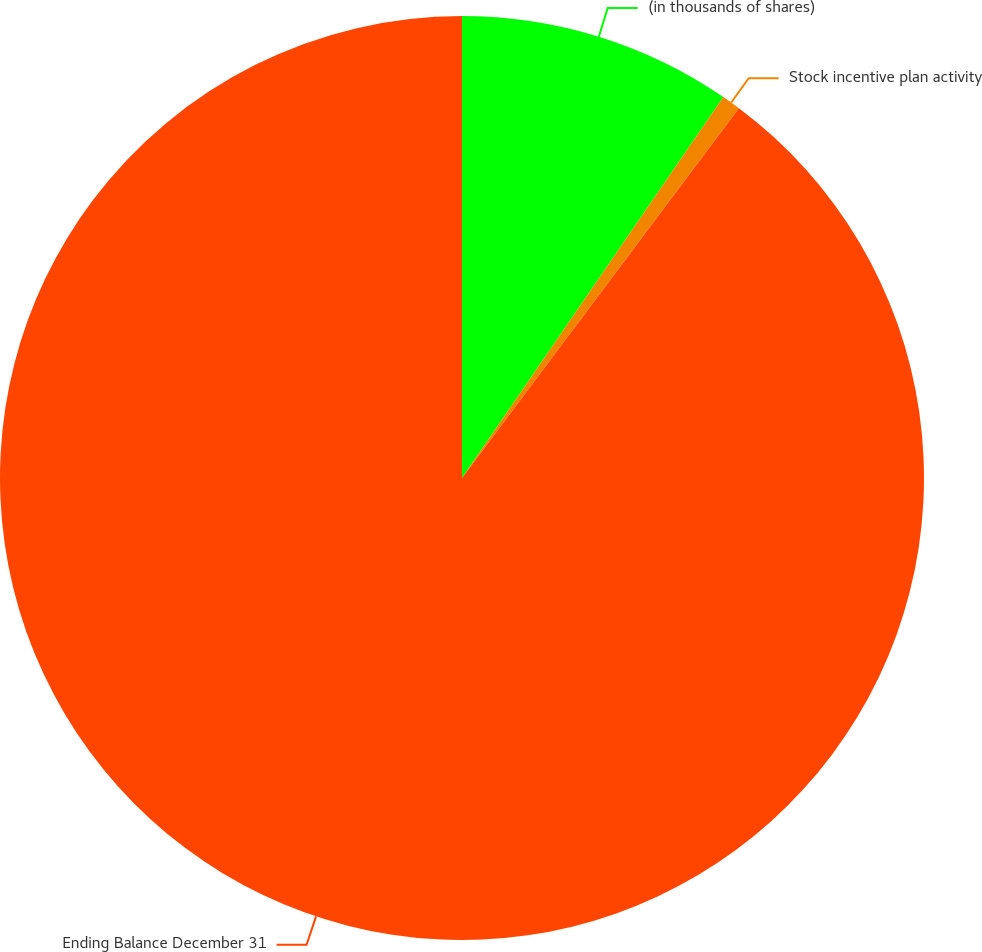Convert chart. <chart><loc_0><loc_0><loc_500><loc_500><pie_chart><fcel>(in thousands of shares)<fcel>Stock incentive plan activity<fcel>Ending Balance December 31<nl><fcel>9.57%<fcel>0.66%<fcel>89.77%<nl></chart> 